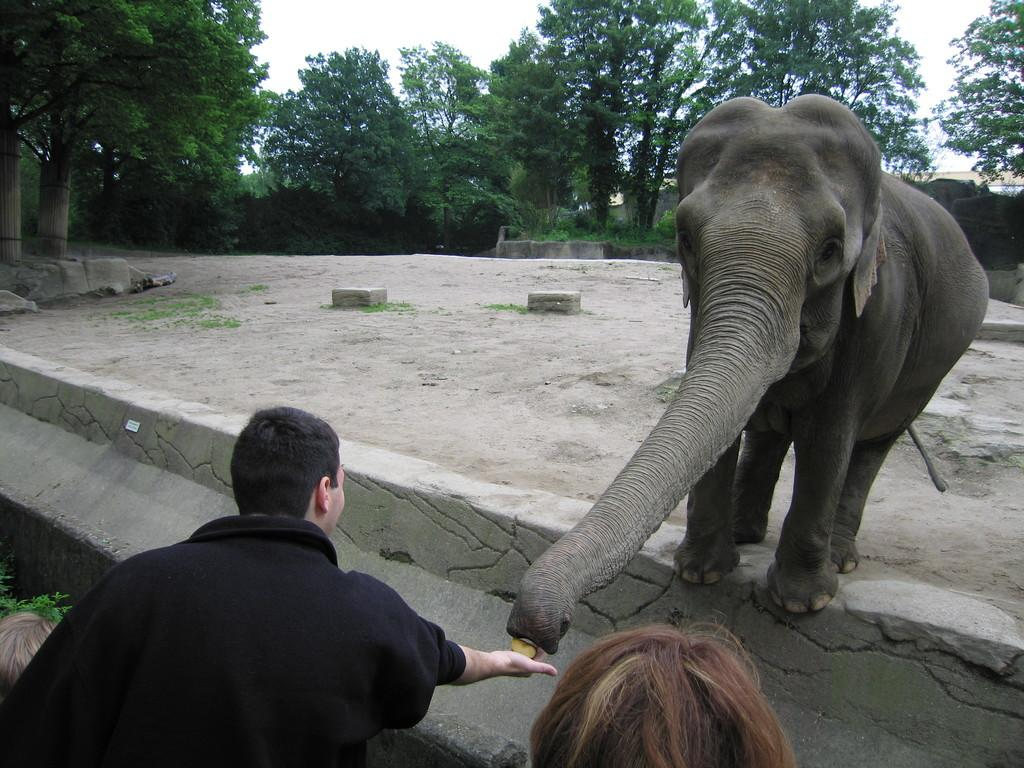What animal is present in the picture? There is an elephant in the picture. Who is in the picture with the elephant? There is a person in the picture. What is the person wearing? The person is wearing a black dress. What is the person doing with the elephant? The person is feeding the elephant. What type of toy can be seen in the person's hand while they are feeding the elephant? There is no toy present in the image; the person is feeding the elephant directly. 